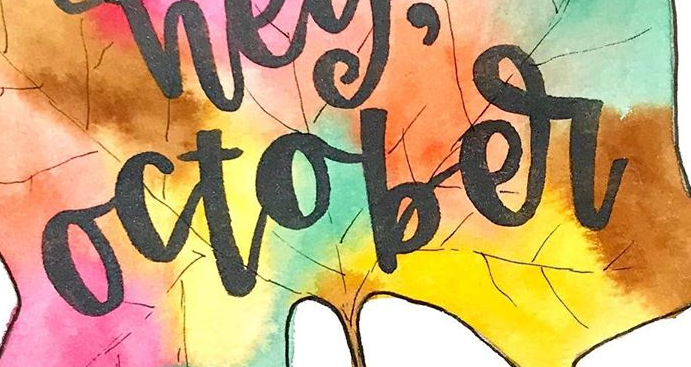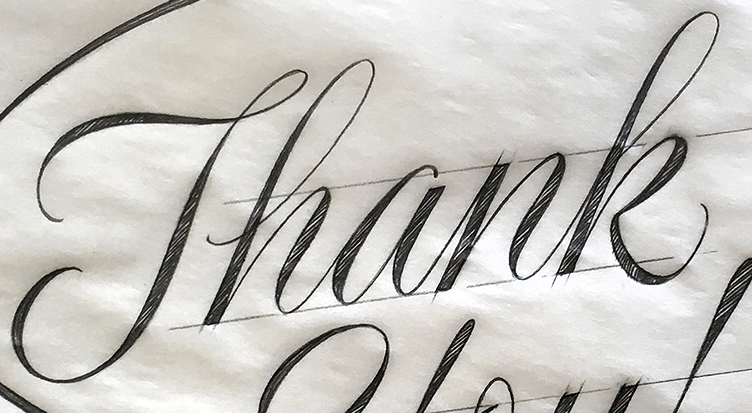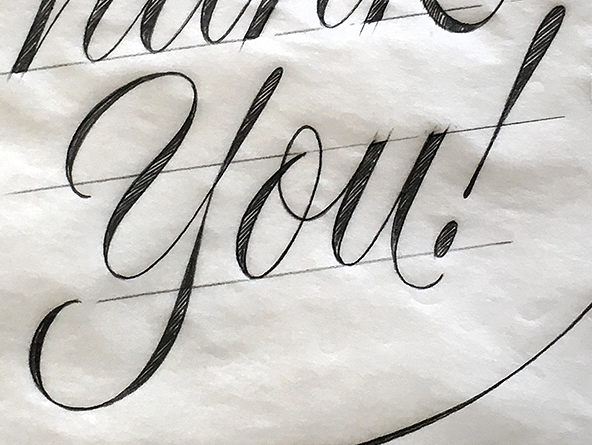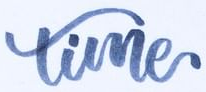What words can you see in these images in sequence, separated by a semicolon? october; Thank; you!; time 